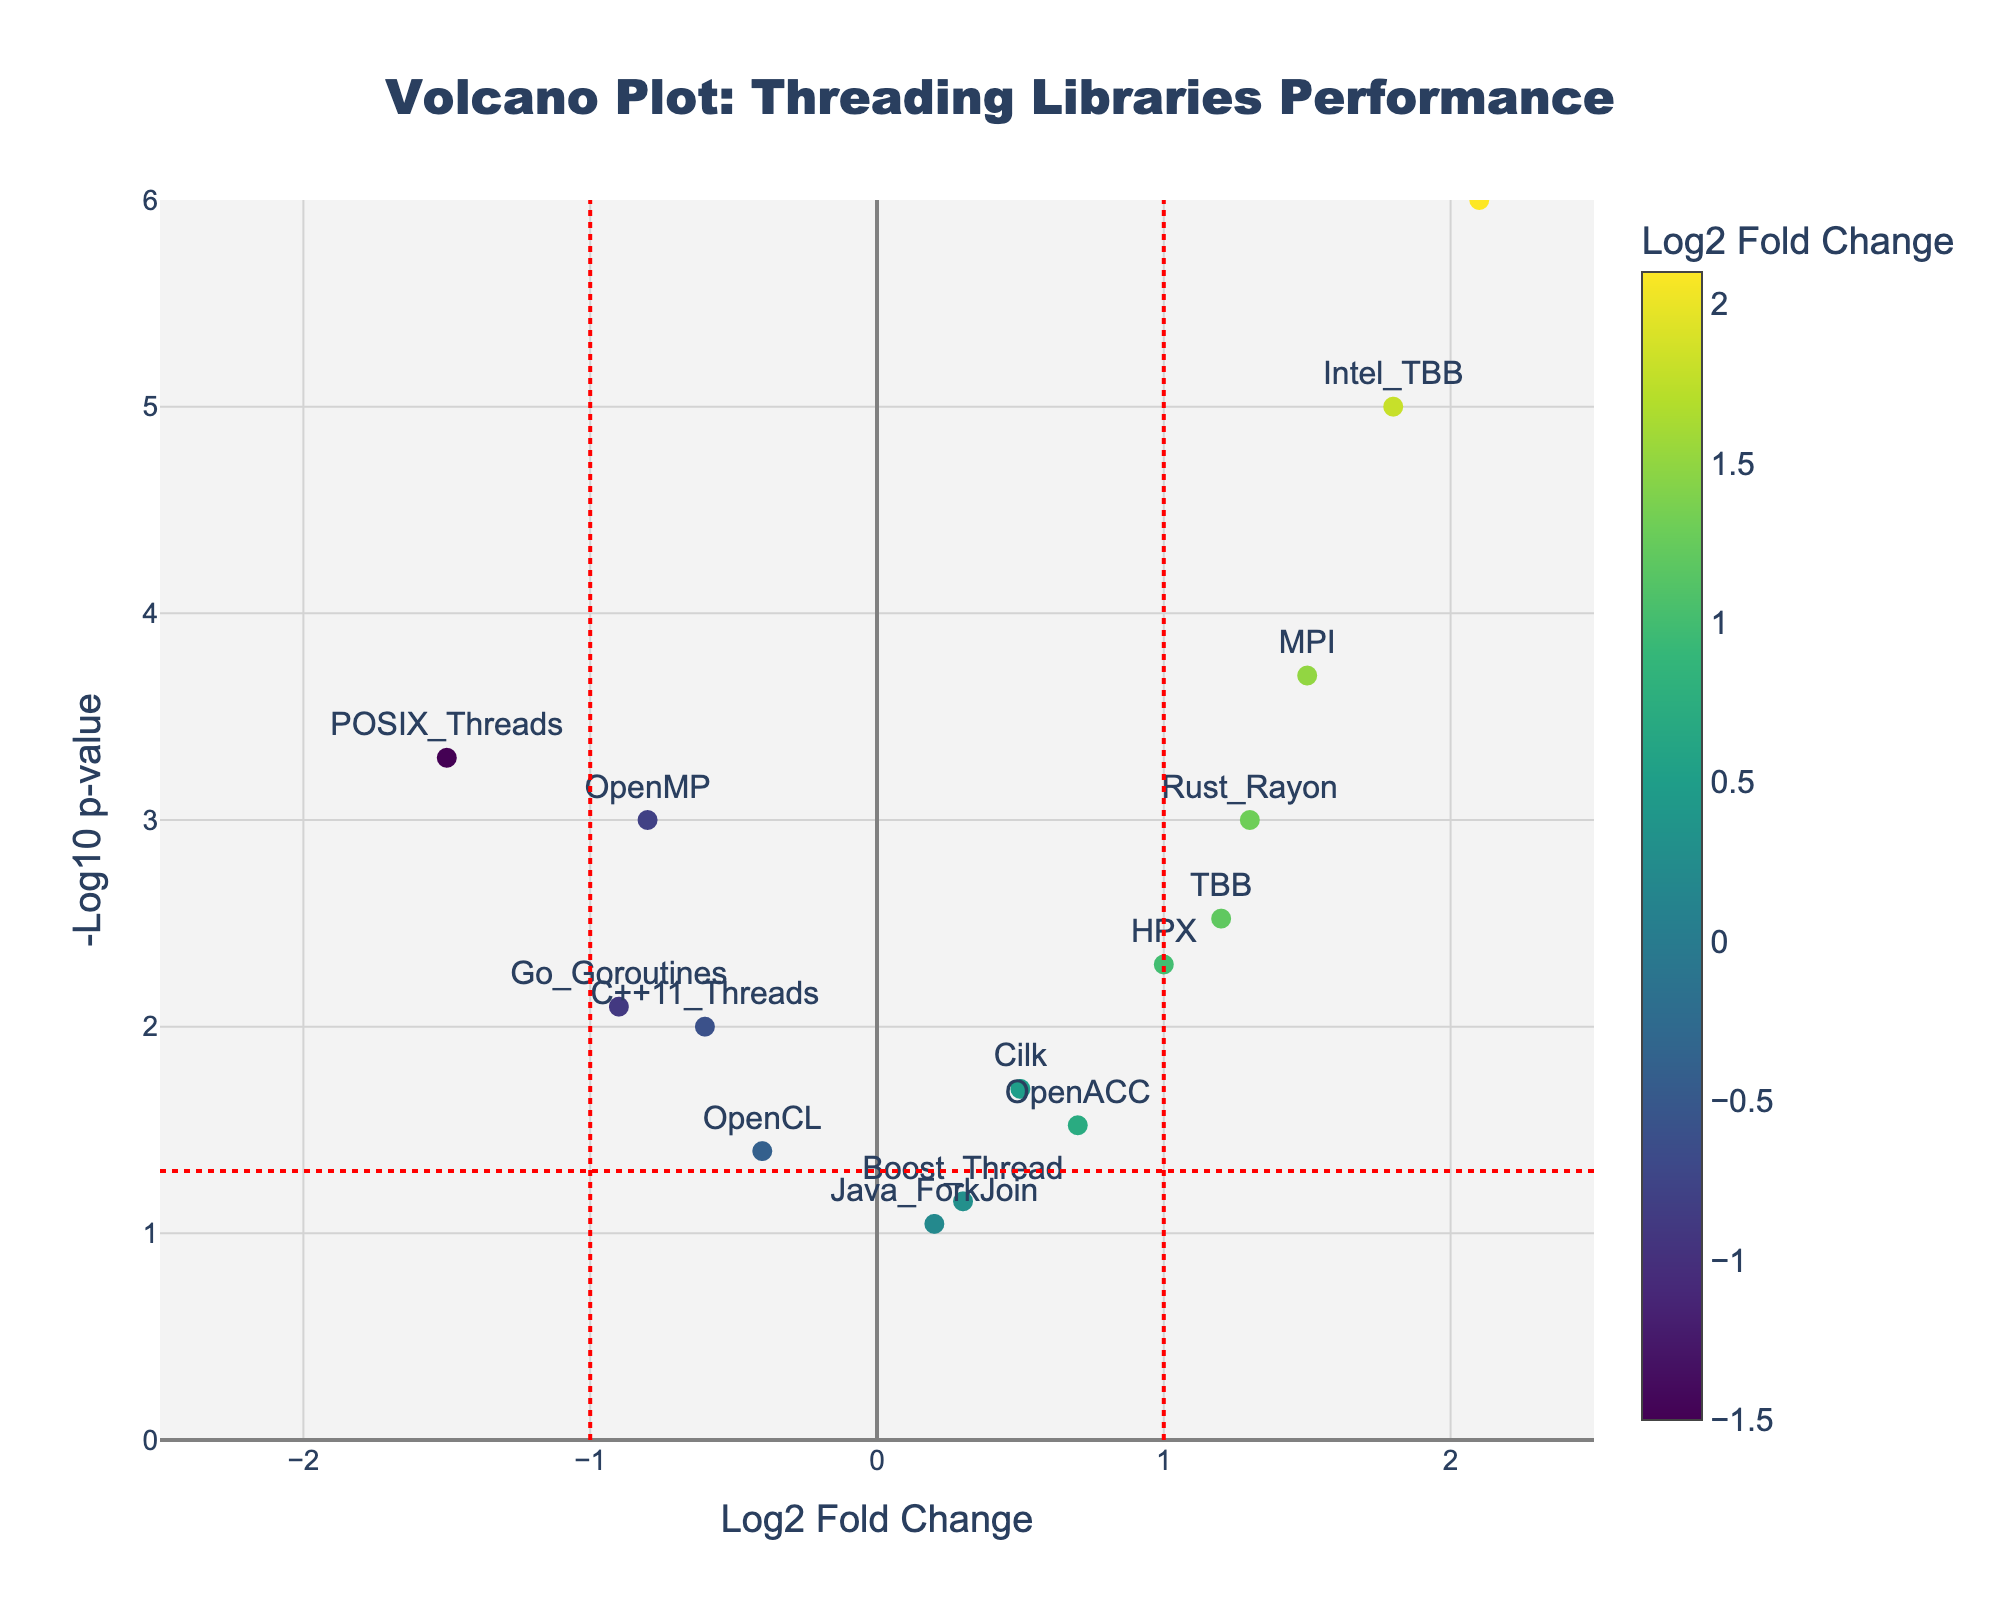What is the title of this plot? The title is shown at the top center of the plot. It reads "Volcano Plot: Threading Libraries Performance".
Answer: "Volcano Plot: Threading Libraries Performance" How many data points are on the plot? Count each of the markers on the plot. There are 15 markers, each representing a different threading library.
Answer: 15 Which threading library has the highest -log10(p-value)? Find the marker with the highest y-axis value. The CUDA marker is the highest on the y-axis.
Answer: CUDA Which threading library has the lowest log2 fold change? Find the marker with the lowest x-axis value. POSIX_Threads has the lowest x-axis value at -1.5.
Answer: POSIX_Threads What is the log2 fold change for the OpenMP library? Locate the OpenMP marker on the plot and read its x-axis position. The log2 fold change for OpenMP is -0.8.
Answer: -0.8 Which threading libraries have a significant p-value (below 0.05) and a positive log2 fold change? Identify the markers that are above the horizontal red dashed line (significant p-value) and to the right of the vertical dashed line at x=0 (positive log2 fold change). The threading libraries are TBB, Intel TBB, HPX, and MPI.
Answer: TBB, Intel TBB, HPX, MPI Which threading libraries have a log2 fold change greater than 1? Identify the markers to the right of the vertical dashed line at x=1. The threading libraries are TBB, Intel TBB, MPI, Rust Rayon, and CUDA.
Answer: TBB, Intel TBB, MPI, Rust Rayon, CUDA What is the difference in log2 fold change between the highest positive and highest negative threading libraries? The highest positive log2 fold change is from CUDA (2.1) and the highest negative log2 fold change is from POSIX Threads (-1.5). The difference is calculated as 2.1 - (-1.5).
Answer: 3.6 What are the threading libraries with p-values below 0.01? Identify the markers above the horizontal red dashed line at y=-log10(0.01). The threading libraries are OpenMP, TBB, POSIX Threads, Intel TBB, MPI, Go Goroutines, and Rust Rayon.
Answer: OpenMP, TBB, POSIX Threads, Intel TBB, MPI, Go Goroutines, Rust Rayon 